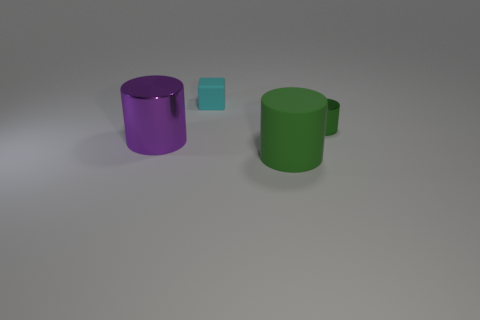Subtract all big rubber cylinders. How many cylinders are left? 2 Add 3 cyan shiny blocks. How many objects exist? 7 Subtract 3 cylinders. How many cylinders are left? 0 Subtract all purple cylinders. How many cylinders are left? 2 Subtract all cylinders. How many objects are left? 1 Subtract all yellow balls. How many brown cylinders are left? 0 Subtract all big cyan matte spheres. Subtract all purple metallic cylinders. How many objects are left? 3 Add 3 big cylinders. How many big cylinders are left? 5 Add 4 matte objects. How many matte objects exist? 6 Subtract 2 green cylinders. How many objects are left? 2 